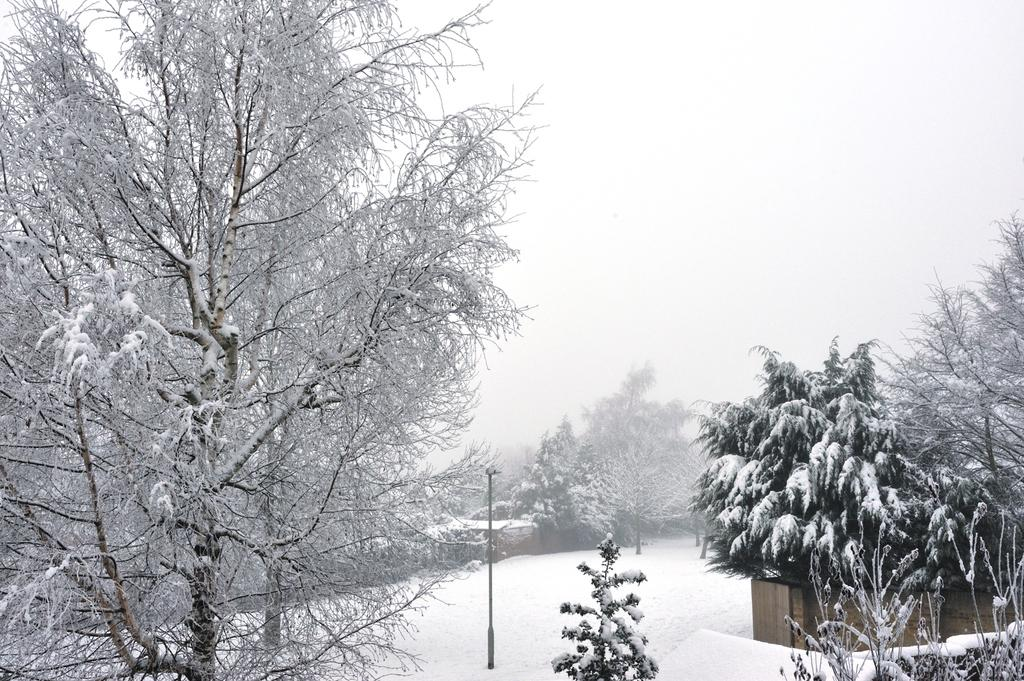What is the primary feature of the landscape in the image? There are many trees in the image. How are the trees in the image affected by the weather? The trees are covered in snow. What is the condition of the ground in the image? There is snow on the ground in the image. What type of transport can be seen in the image? There is no transport visible in the image; it primarily features trees and snow. What property is being sold in the image? There is no property being sold in the image; it is a landscape scene with trees and snow. 